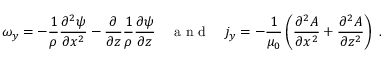Convert formula to latex. <formula><loc_0><loc_0><loc_500><loc_500>\omega _ { y } = - \frac { 1 } { \rho } \frac { \partial ^ { 2 } \psi } { \partial x ^ { 2 } } - \frac { \partial } { \partial z } \frac { 1 } { \rho } \frac { \partial \psi } { \partial z } \quad a n d \quad j _ { y } = - \frac { 1 } { \mu _ { 0 } } \left ( \frac { \partial ^ { 2 } A } { \partial x ^ { 2 } } + \frac { \partial ^ { 2 } A } { \partial z ^ { 2 } } \right ) \, .</formula> 